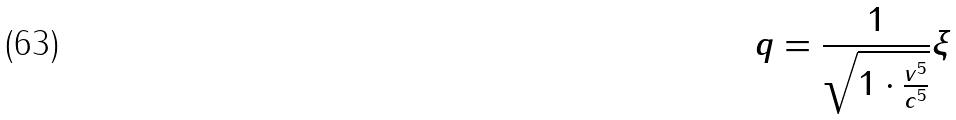Convert formula to latex. <formula><loc_0><loc_0><loc_500><loc_500>q = \frac { 1 } { \sqrt { 1 \cdot \frac { v ^ { 5 } } { c ^ { 5 } } } } \xi</formula> 